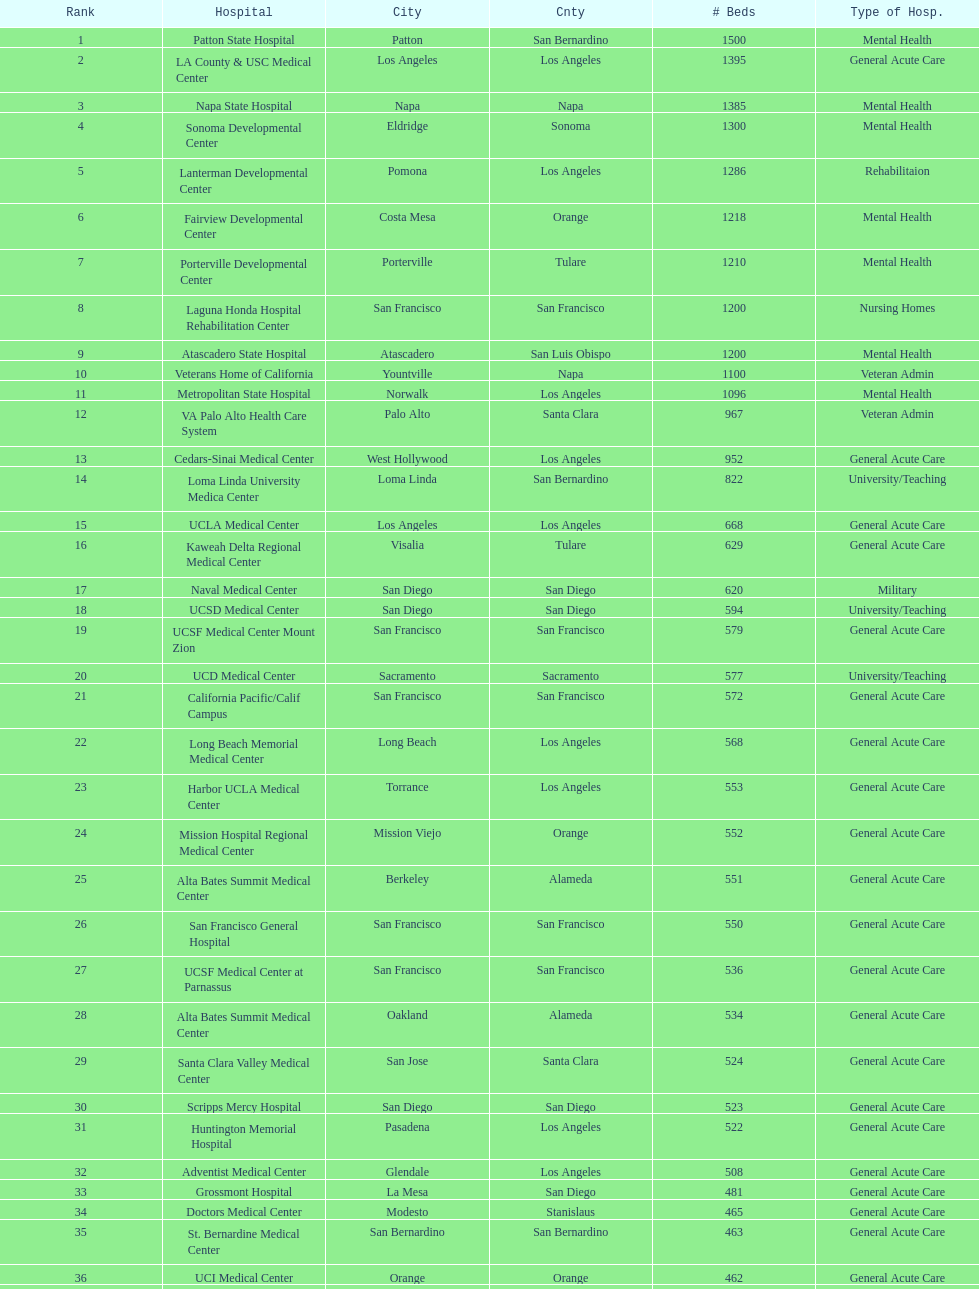How many more general acute care hospitals are there in california than rehabilitation hospitals? 33. 